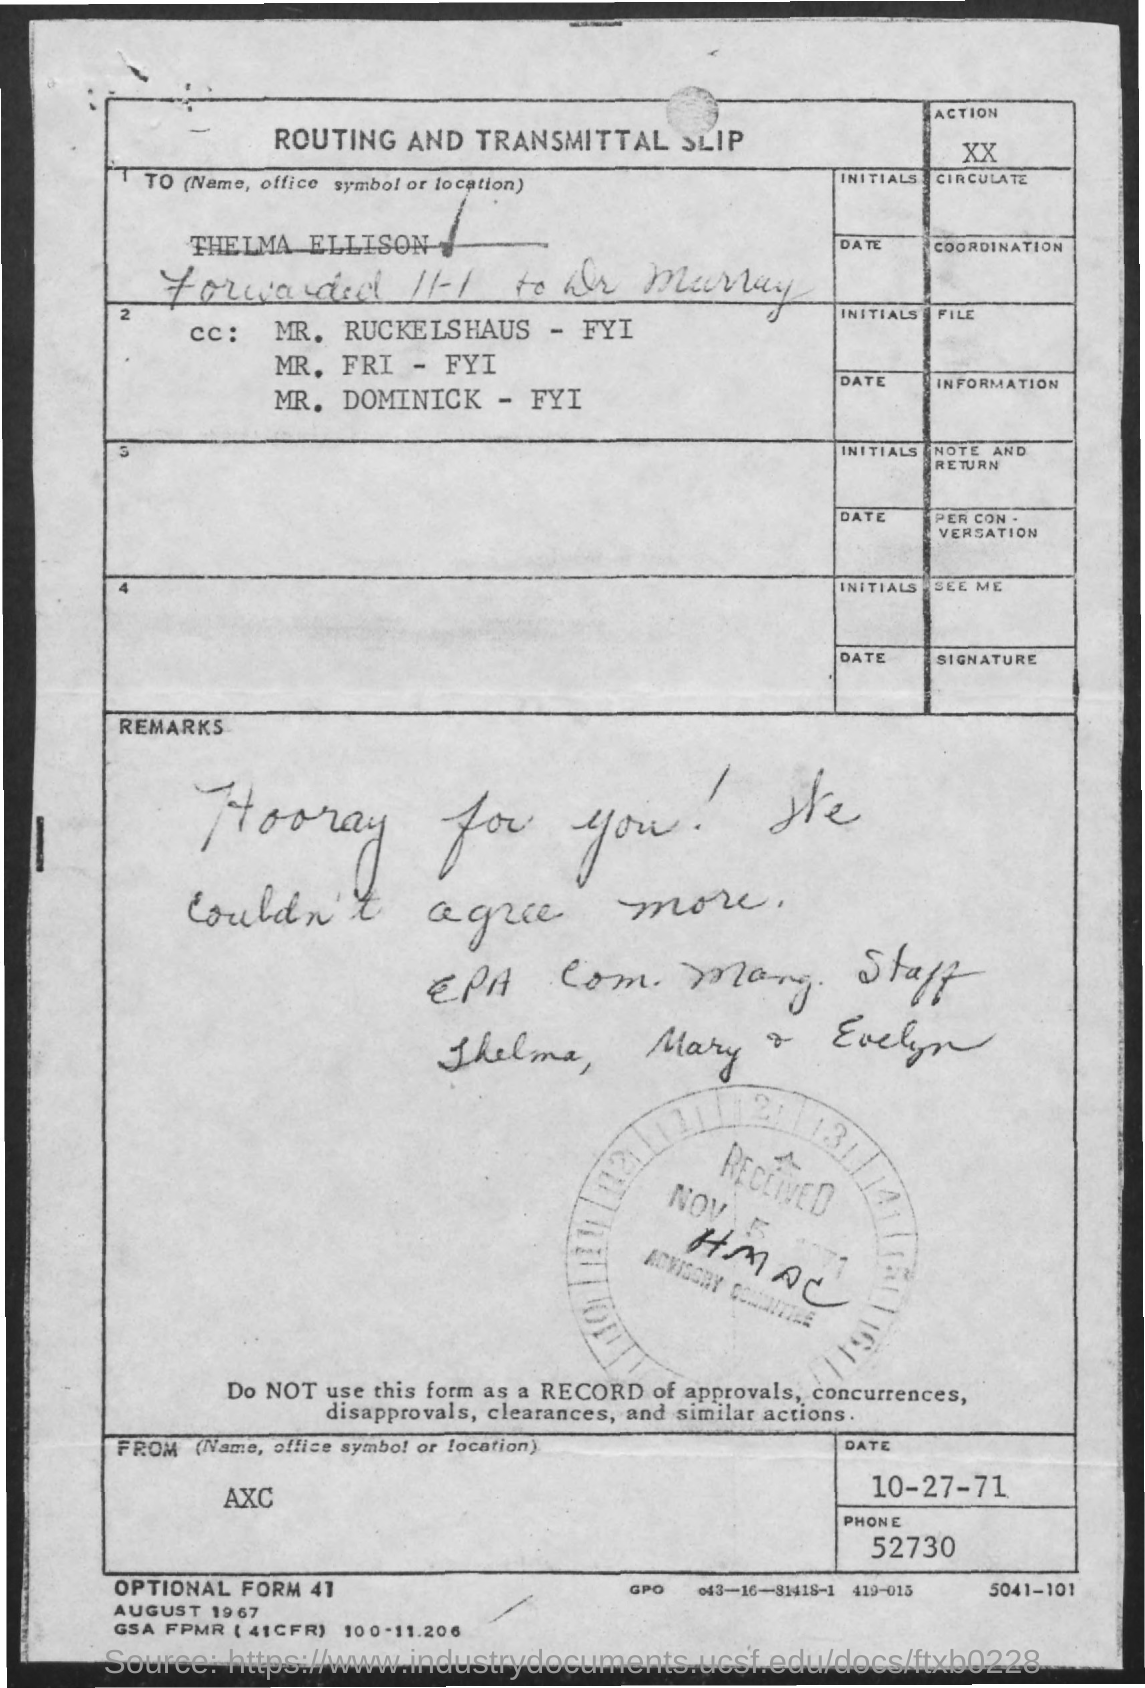What is the phone no. mentioned ?
Offer a very short reply. 52730. What is the date mentioned ?
Give a very brief answer. 10-27-71. What is the received date mentioned ?
Offer a very short reply. Nov 5 1971. 